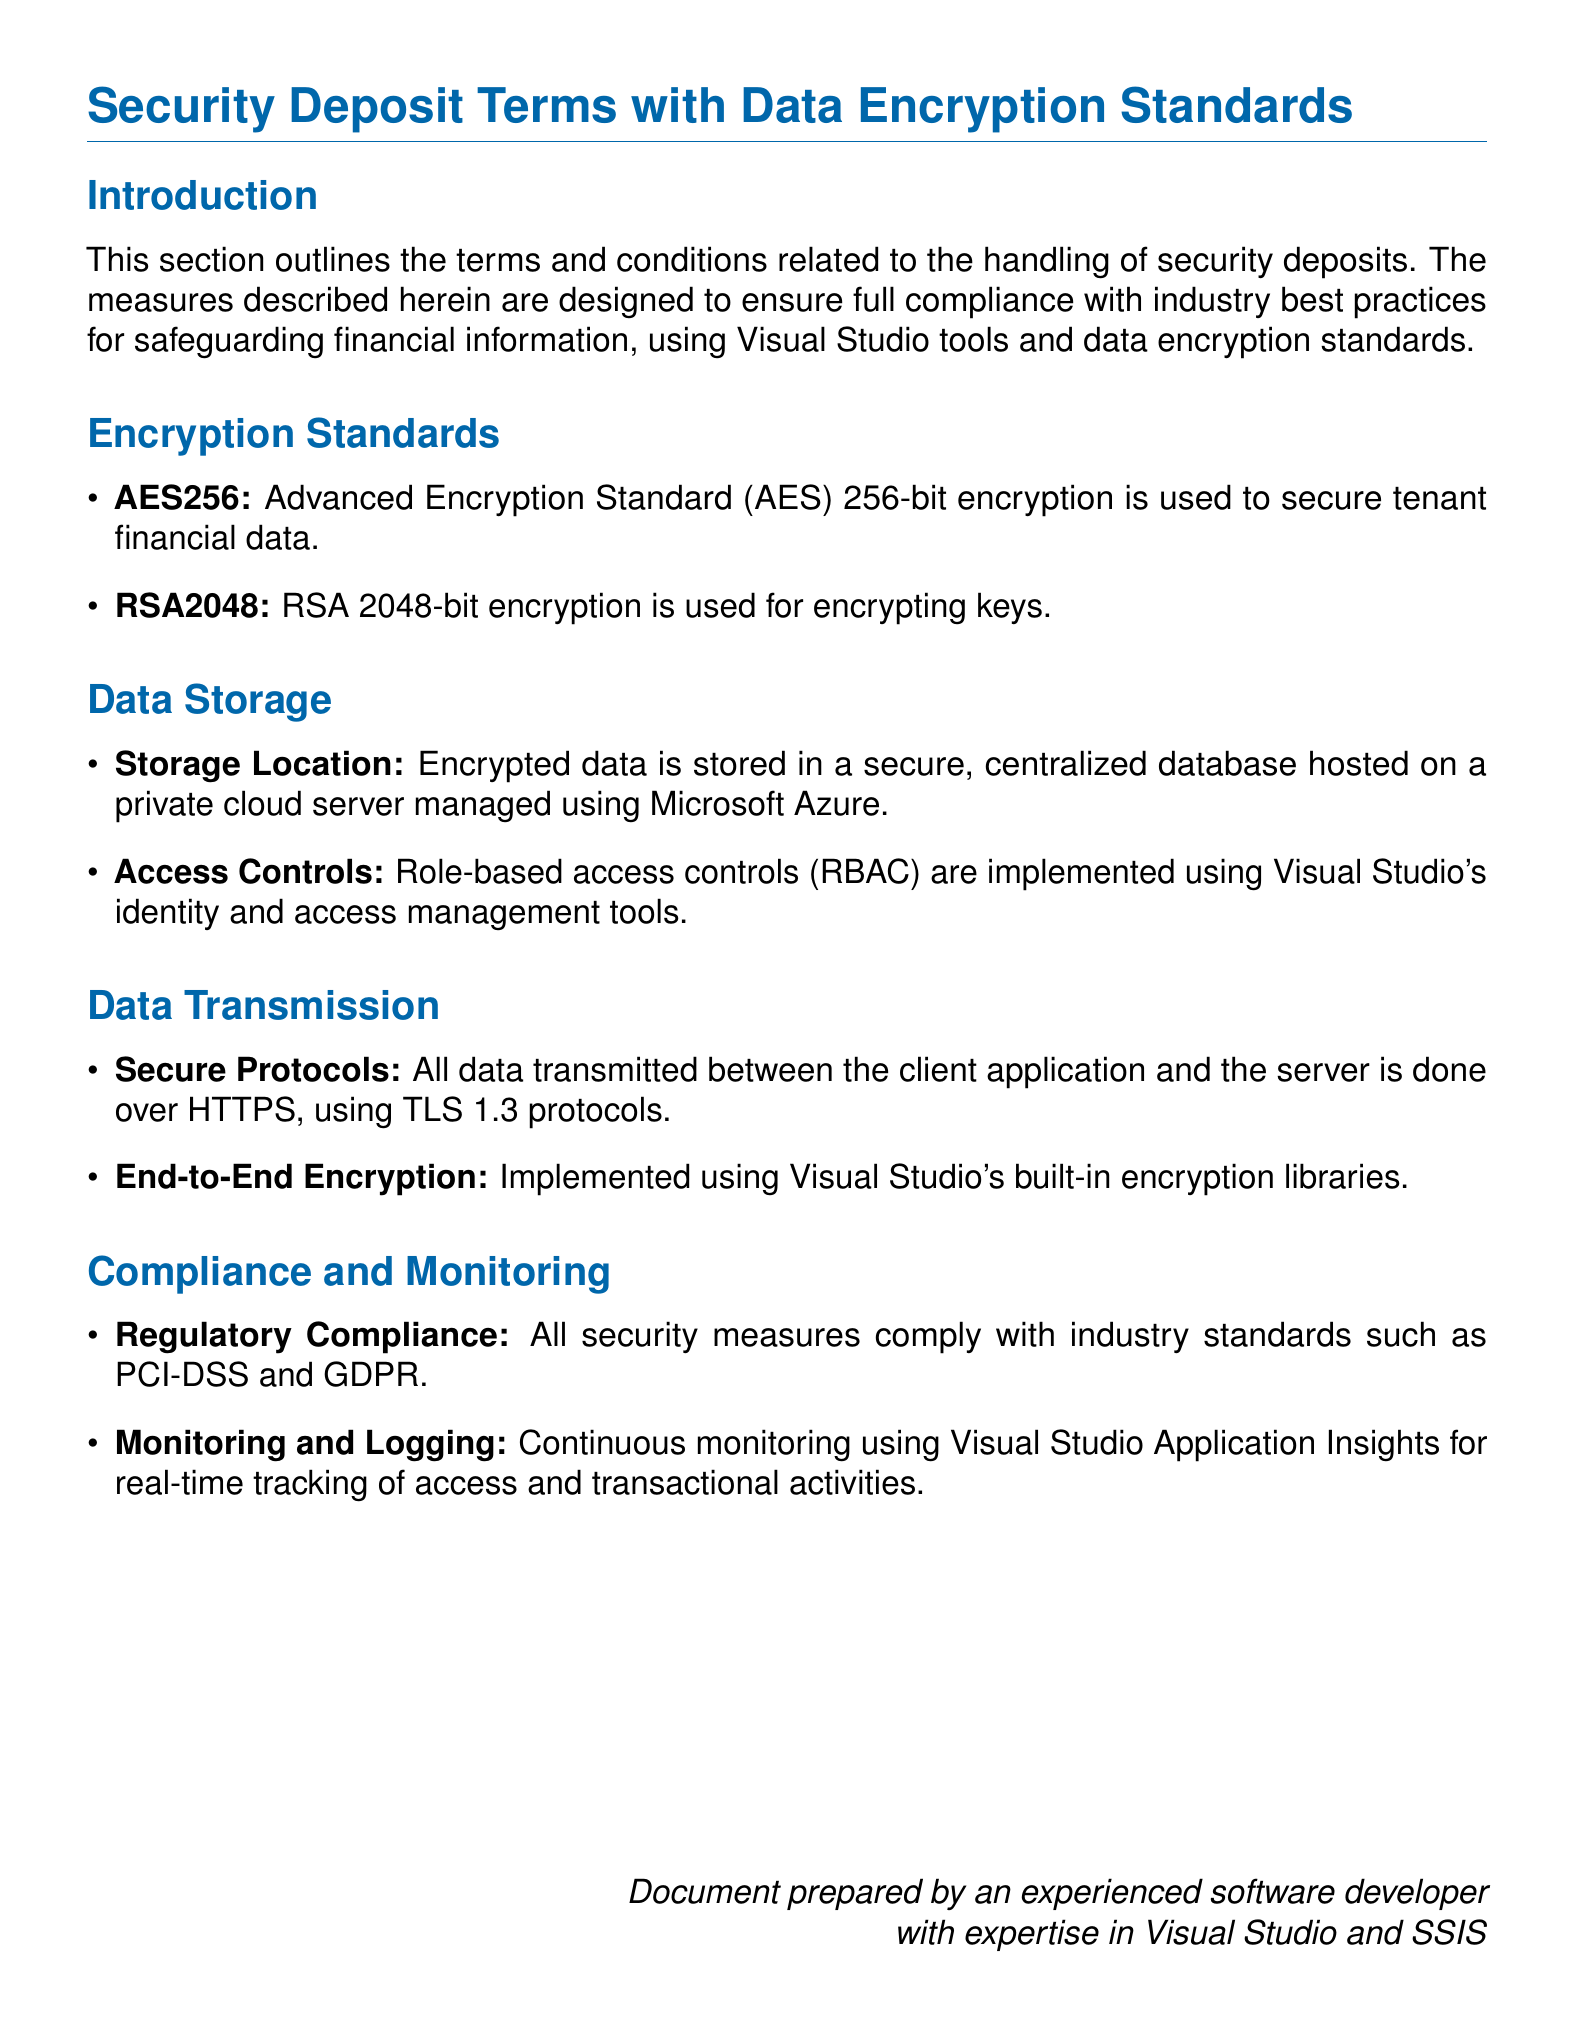What encryption standard is used for tenant financial data? The document specifies that Advanced Encryption Standard with 256-bit encryption (AES256) is used to secure tenant financial data.
Answer: AES256 What is the encryption method for keys? The document mentions that RSA 2048-bit encryption (RSA2048) is used for encrypting keys.
Answer: RSA2048 Where is the encrypted data stored? According to the document, encrypted data is stored in a secure, centralized database on a private cloud server managed using Microsoft Azure.
Answer: Private cloud server What protocol is used for data transmission? The document states that all data is transmitted over HTTPS using TLS 1.3 protocols.
Answer: HTTPS, TLS 1.3 What compliance standards are mentioned in the document? The document indicates that security measures comply with industry standards such as PCI-DSS and GDPR.
Answer: PCI-DSS, GDPR Which Visual Studio feature is used for access controls? The document describes that role-based access controls (RBAC) are implemented using Visual Studio's identity and access management tools.
Answer: Identity and access management tools What is the purpose of Visual Studio Application Insights according to the document? The document states that Visual Studio Application Insights is used for continuous monitoring and real-time tracking of access and transactional activities.
Answer: Continuous monitoring What type of encryption is used for data transmission? The document mentions that end-to-end encryption is implemented using Visual Studio's built-in encryption libraries.
Answer: End-to-end encryption 